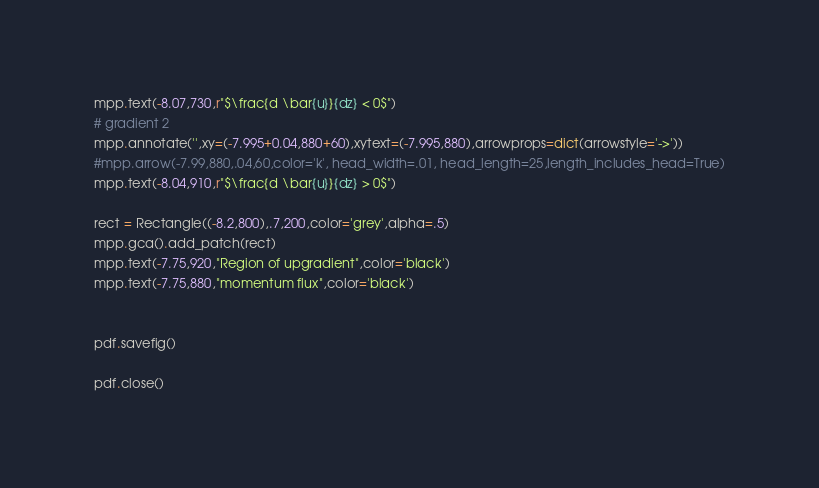Convert code to text. <code><loc_0><loc_0><loc_500><loc_500><_Python_>mpp.text(-8.07,730,r"$\frac{d \bar{u}}{dz} < 0$")
# gradient 2
mpp.annotate('',xy=(-7.995+0.04,880+60),xytext=(-7.995,880),arrowprops=dict(arrowstyle='->'))
#mpp.arrow(-7.99,880,.04,60,color='k', head_width=.01, head_length=25,length_includes_head=True)
mpp.text(-8.04,910,r"$\frac{d \bar{u}}{dz} > 0$")

rect = Rectangle((-8.2,800),.7,200,color='grey',alpha=.5)
mpp.gca().add_patch(rect)
mpp.text(-7.75,920,"Region of upgradient",color='black')
mpp.text(-7.75,880,"momentum flux",color='black')


pdf.savefig()

pdf.close()</code> 